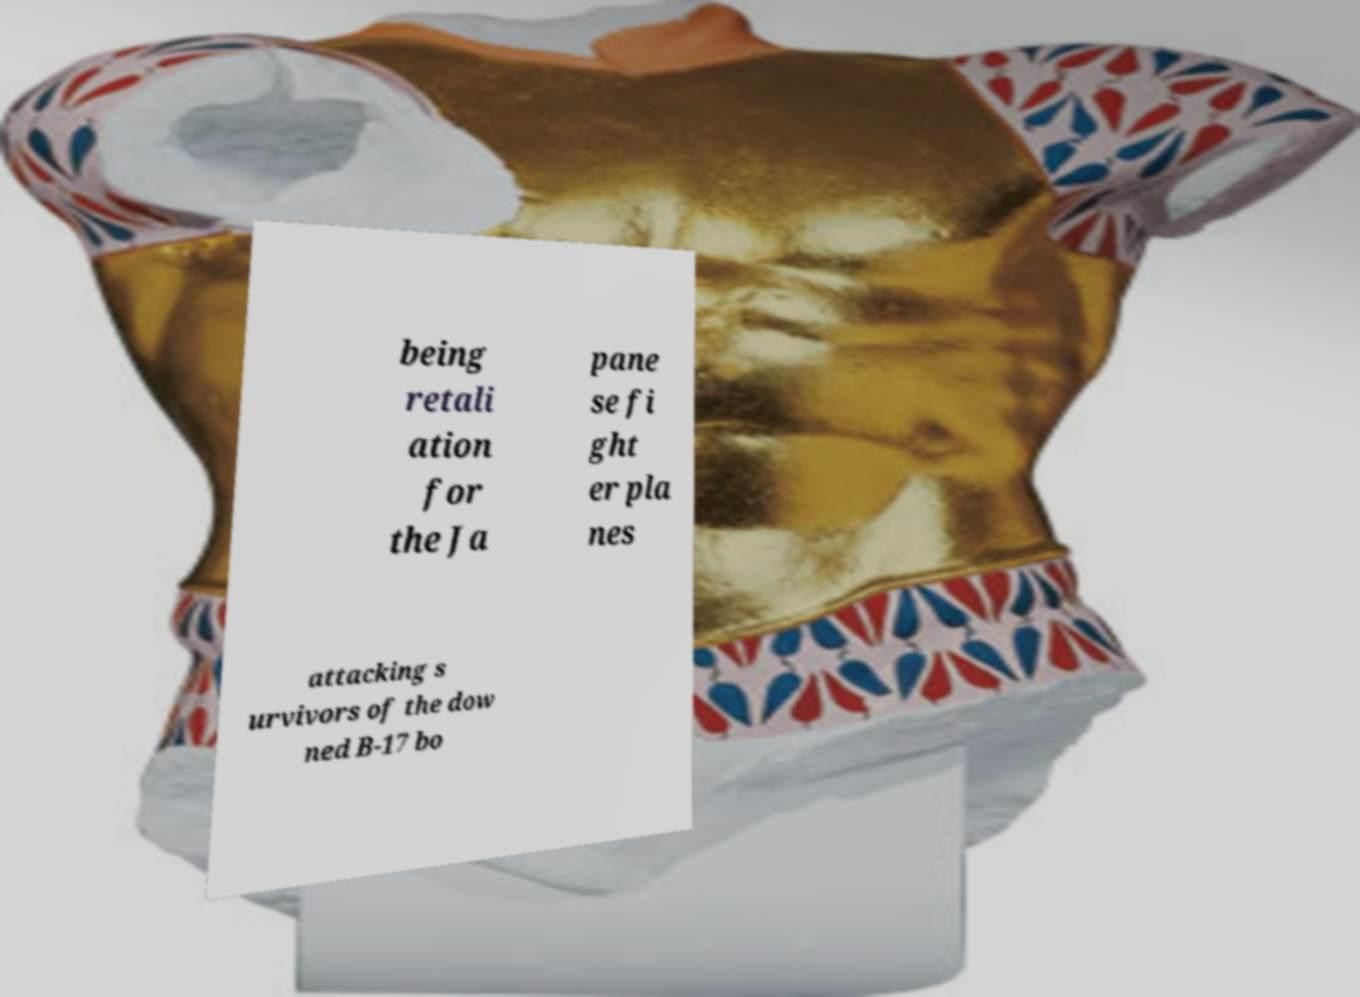Could you assist in decoding the text presented in this image and type it out clearly? being retali ation for the Ja pane se fi ght er pla nes attacking s urvivors of the dow ned B-17 bo 